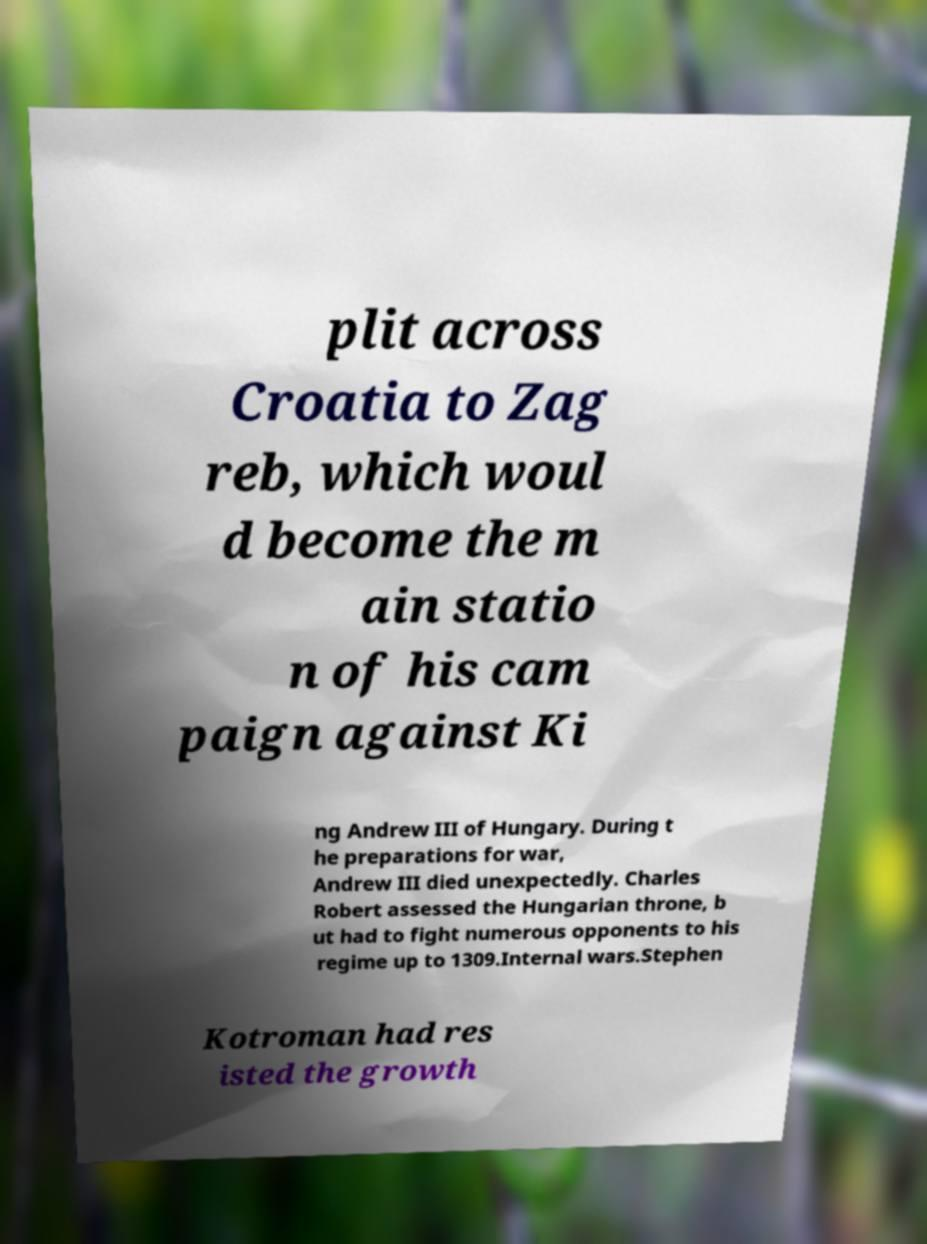Could you assist in decoding the text presented in this image and type it out clearly? plit across Croatia to Zag reb, which woul d become the m ain statio n of his cam paign against Ki ng Andrew III of Hungary. During t he preparations for war, Andrew III died unexpectedly. Charles Robert assessed the Hungarian throne, b ut had to fight numerous opponents to his regime up to 1309.Internal wars.Stephen Kotroman had res isted the growth 